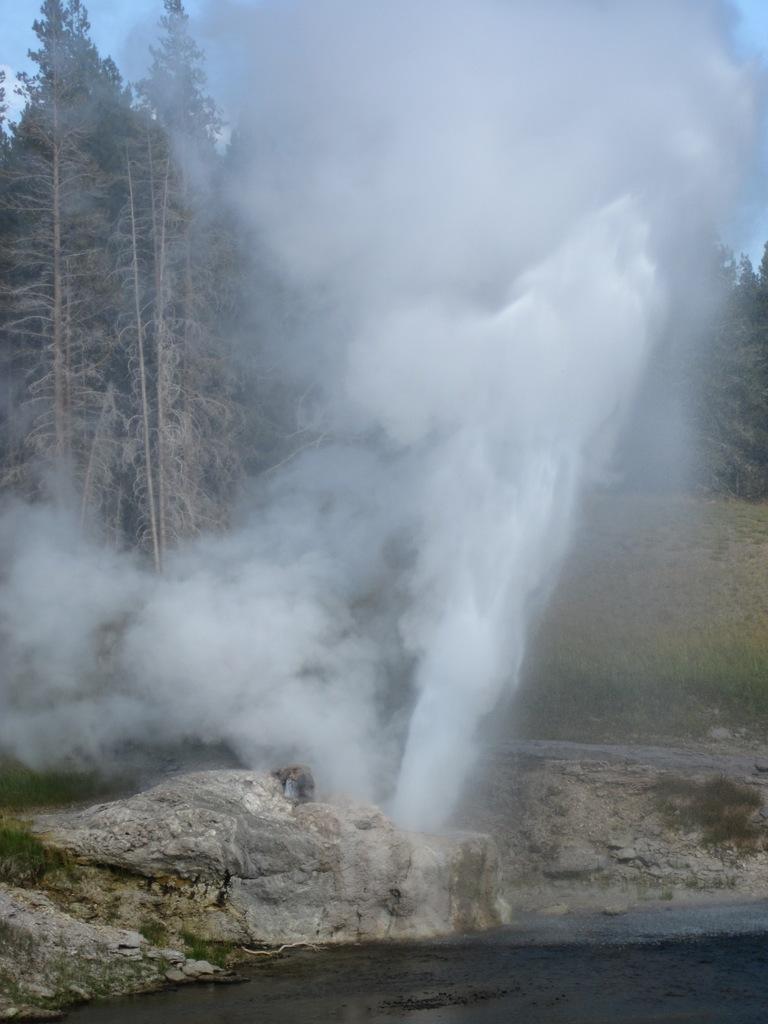Can you describe this image briefly? In the center of the image we can see the sky, trees, grass, rocks, water and the hot spring. 